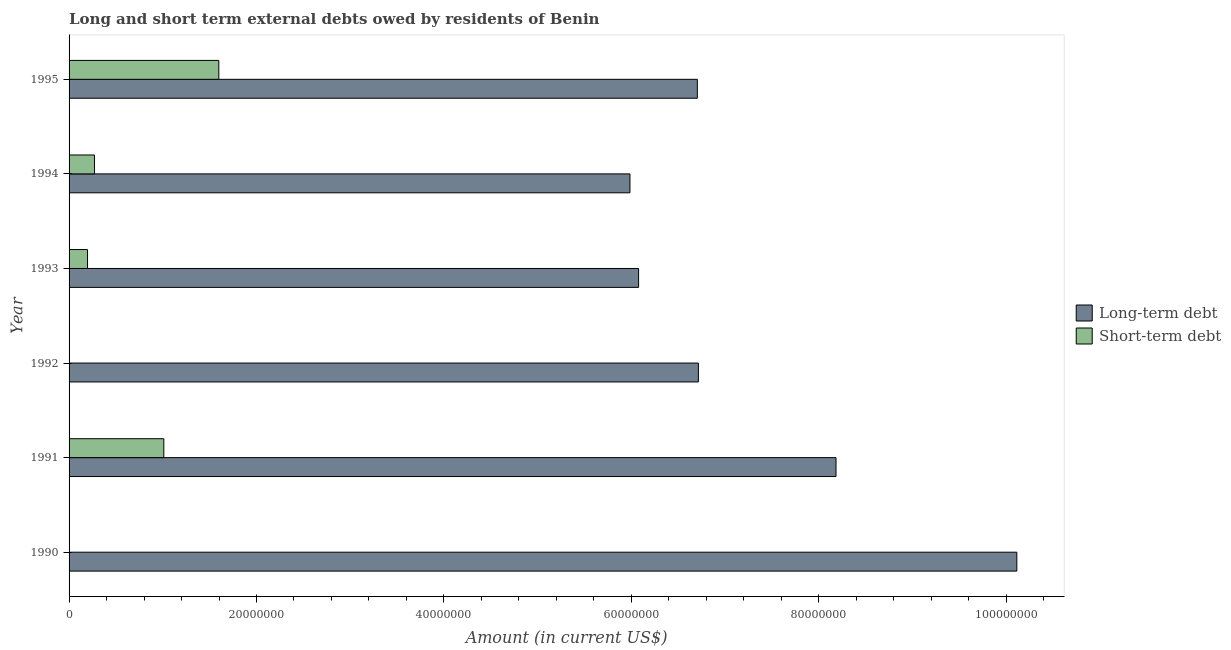Are the number of bars per tick equal to the number of legend labels?
Your answer should be very brief. No. Are the number of bars on each tick of the Y-axis equal?
Provide a short and direct response. No. How many bars are there on the 6th tick from the bottom?
Ensure brevity in your answer.  2. In how many cases, is the number of bars for a given year not equal to the number of legend labels?
Give a very brief answer. 2. What is the long-term debts owed by residents in 1991?
Offer a terse response. 8.18e+07. Across all years, what is the maximum long-term debts owed by residents?
Give a very brief answer. 1.01e+08. Across all years, what is the minimum long-term debts owed by residents?
Your answer should be compact. 5.99e+07. What is the total short-term debts owed by residents in the graph?
Your answer should be compact. 3.08e+07. What is the difference between the long-term debts owed by residents in 1990 and that in 1991?
Keep it short and to the point. 1.93e+07. What is the difference between the long-term debts owed by residents in 1994 and the short-term debts owed by residents in 1993?
Provide a succinct answer. 5.79e+07. What is the average long-term debts owed by residents per year?
Your answer should be compact. 7.30e+07. In the year 1995, what is the difference between the long-term debts owed by residents and short-term debts owed by residents?
Provide a succinct answer. 5.11e+07. In how many years, is the long-term debts owed by residents greater than 80000000 US$?
Offer a terse response. 2. What is the ratio of the long-term debts owed by residents in 1992 to that in 1995?
Give a very brief answer. 1. Is the short-term debts owed by residents in 1991 less than that in 1993?
Give a very brief answer. No. What is the difference between the highest and the second highest long-term debts owed by residents?
Give a very brief answer. 1.93e+07. What is the difference between the highest and the lowest short-term debts owed by residents?
Your answer should be very brief. 1.60e+07. Is the sum of the short-term debts owed by residents in 1991 and 1995 greater than the maximum long-term debts owed by residents across all years?
Ensure brevity in your answer.  No. Are all the bars in the graph horizontal?
Give a very brief answer. Yes. Does the graph contain any zero values?
Your answer should be compact. Yes. Does the graph contain grids?
Your response must be concise. No. Where does the legend appear in the graph?
Provide a short and direct response. Center right. How are the legend labels stacked?
Keep it short and to the point. Vertical. What is the title of the graph?
Give a very brief answer. Long and short term external debts owed by residents of Benin. Does "Pregnant women" appear as one of the legend labels in the graph?
Provide a succinct answer. No. What is the Amount (in current US$) in Long-term debt in 1990?
Make the answer very short. 1.01e+08. What is the Amount (in current US$) of Long-term debt in 1991?
Your response must be concise. 8.18e+07. What is the Amount (in current US$) of Short-term debt in 1991?
Make the answer very short. 1.01e+07. What is the Amount (in current US$) of Long-term debt in 1992?
Your answer should be very brief. 6.72e+07. What is the Amount (in current US$) of Long-term debt in 1993?
Your answer should be very brief. 6.08e+07. What is the Amount (in current US$) in Short-term debt in 1993?
Offer a very short reply. 1.97e+06. What is the Amount (in current US$) of Long-term debt in 1994?
Give a very brief answer. 5.99e+07. What is the Amount (in current US$) in Short-term debt in 1994?
Ensure brevity in your answer.  2.71e+06. What is the Amount (in current US$) in Long-term debt in 1995?
Offer a terse response. 6.70e+07. What is the Amount (in current US$) in Short-term debt in 1995?
Provide a succinct answer. 1.60e+07. Across all years, what is the maximum Amount (in current US$) of Long-term debt?
Your answer should be very brief. 1.01e+08. Across all years, what is the maximum Amount (in current US$) in Short-term debt?
Offer a terse response. 1.60e+07. Across all years, what is the minimum Amount (in current US$) in Long-term debt?
Keep it short and to the point. 5.99e+07. Across all years, what is the minimum Amount (in current US$) in Short-term debt?
Give a very brief answer. 0. What is the total Amount (in current US$) of Long-term debt in the graph?
Make the answer very short. 4.38e+08. What is the total Amount (in current US$) of Short-term debt in the graph?
Make the answer very short. 3.08e+07. What is the difference between the Amount (in current US$) in Long-term debt in 1990 and that in 1991?
Your answer should be very brief. 1.93e+07. What is the difference between the Amount (in current US$) in Long-term debt in 1990 and that in 1992?
Make the answer very short. 3.40e+07. What is the difference between the Amount (in current US$) in Long-term debt in 1990 and that in 1993?
Keep it short and to the point. 4.04e+07. What is the difference between the Amount (in current US$) in Long-term debt in 1990 and that in 1994?
Offer a terse response. 4.13e+07. What is the difference between the Amount (in current US$) of Long-term debt in 1990 and that in 1995?
Your answer should be compact. 3.41e+07. What is the difference between the Amount (in current US$) in Long-term debt in 1991 and that in 1992?
Your answer should be very brief. 1.47e+07. What is the difference between the Amount (in current US$) of Long-term debt in 1991 and that in 1993?
Your answer should be very brief. 2.11e+07. What is the difference between the Amount (in current US$) of Short-term debt in 1991 and that in 1993?
Give a very brief answer. 8.14e+06. What is the difference between the Amount (in current US$) of Long-term debt in 1991 and that in 1994?
Your answer should be compact. 2.20e+07. What is the difference between the Amount (in current US$) in Short-term debt in 1991 and that in 1994?
Keep it short and to the point. 7.40e+06. What is the difference between the Amount (in current US$) of Long-term debt in 1991 and that in 1995?
Give a very brief answer. 1.48e+07. What is the difference between the Amount (in current US$) of Short-term debt in 1991 and that in 1995?
Keep it short and to the point. -5.87e+06. What is the difference between the Amount (in current US$) of Long-term debt in 1992 and that in 1993?
Your response must be concise. 6.38e+06. What is the difference between the Amount (in current US$) in Long-term debt in 1992 and that in 1994?
Provide a short and direct response. 7.30e+06. What is the difference between the Amount (in current US$) of Long-term debt in 1992 and that in 1995?
Your answer should be very brief. 1.13e+05. What is the difference between the Amount (in current US$) in Long-term debt in 1993 and that in 1994?
Your answer should be compact. 9.23e+05. What is the difference between the Amount (in current US$) in Short-term debt in 1993 and that in 1994?
Give a very brief answer. -7.40e+05. What is the difference between the Amount (in current US$) in Long-term debt in 1993 and that in 1995?
Keep it short and to the point. -6.27e+06. What is the difference between the Amount (in current US$) in Short-term debt in 1993 and that in 1995?
Offer a very short reply. -1.40e+07. What is the difference between the Amount (in current US$) of Long-term debt in 1994 and that in 1995?
Keep it short and to the point. -7.19e+06. What is the difference between the Amount (in current US$) of Short-term debt in 1994 and that in 1995?
Give a very brief answer. -1.33e+07. What is the difference between the Amount (in current US$) of Long-term debt in 1990 and the Amount (in current US$) of Short-term debt in 1991?
Provide a succinct answer. 9.10e+07. What is the difference between the Amount (in current US$) of Long-term debt in 1990 and the Amount (in current US$) of Short-term debt in 1993?
Your answer should be compact. 9.92e+07. What is the difference between the Amount (in current US$) in Long-term debt in 1990 and the Amount (in current US$) in Short-term debt in 1994?
Offer a very short reply. 9.84e+07. What is the difference between the Amount (in current US$) of Long-term debt in 1990 and the Amount (in current US$) of Short-term debt in 1995?
Ensure brevity in your answer.  8.52e+07. What is the difference between the Amount (in current US$) of Long-term debt in 1991 and the Amount (in current US$) of Short-term debt in 1993?
Keep it short and to the point. 7.99e+07. What is the difference between the Amount (in current US$) of Long-term debt in 1991 and the Amount (in current US$) of Short-term debt in 1994?
Offer a terse response. 7.91e+07. What is the difference between the Amount (in current US$) in Long-term debt in 1991 and the Amount (in current US$) in Short-term debt in 1995?
Offer a very short reply. 6.59e+07. What is the difference between the Amount (in current US$) in Long-term debt in 1992 and the Amount (in current US$) in Short-term debt in 1993?
Keep it short and to the point. 6.52e+07. What is the difference between the Amount (in current US$) in Long-term debt in 1992 and the Amount (in current US$) in Short-term debt in 1994?
Make the answer very short. 6.44e+07. What is the difference between the Amount (in current US$) in Long-term debt in 1992 and the Amount (in current US$) in Short-term debt in 1995?
Offer a very short reply. 5.12e+07. What is the difference between the Amount (in current US$) in Long-term debt in 1993 and the Amount (in current US$) in Short-term debt in 1994?
Offer a very short reply. 5.81e+07. What is the difference between the Amount (in current US$) of Long-term debt in 1993 and the Amount (in current US$) of Short-term debt in 1995?
Offer a very short reply. 4.48e+07. What is the difference between the Amount (in current US$) in Long-term debt in 1994 and the Amount (in current US$) in Short-term debt in 1995?
Offer a terse response. 4.39e+07. What is the average Amount (in current US$) of Long-term debt per year?
Provide a succinct answer. 7.30e+07. What is the average Amount (in current US$) in Short-term debt per year?
Make the answer very short. 5.13e+06. In the year 1991, what is the difference between the Amount (in current US$) of Long-term debt and Amount (in current US$) of Short-term debt?
Offer a very short reply. 7.17e+07. In the year 1993, what is the difference between the Amount (in current US$) in Long-term debt and Amount (in current US$) in Short-term debt?
Ensure brevity in your answer.  5.88e+07. In the year 1994, what is the difference between the Amount (in current US$) in Long-term debt and Amount (in current US$) in Short-term debt?
Offer a very short reply. 5.71e+07. In the year 1995, what is the difference between the Amount (in current US$) in Long-term debt and Amount (in current US$) in Short-term debt?
Provide a succinct answer. 5.11e+07. What is the ratio of the Amount (in current US$) in Long-term debt in 1990 to that in 1991?
Your answer should be compact. 1.24. What is the ratio of the Amount (in current US$) in Long-term debt in 1990 to that in 1992?
Keep it short and to the point. 1.51. What is the ratio of the Amount (in current US$) of Long-term debt in 1990 to that in 1993?
Provide a succinct answer. 1.66. What is the ratio of the Amount (in current US$) in Long-term debt in 1990 to that in 1994?
Your answer should be very brief. 1.69. What is the ratio of the Amount (in current US$) of Long-term debt in 1990 to that in 1995?
Your answer should be compact. 1.51. What is the ratio of the Amount (in current US$) of Long-term debt in 1991 to that in 1992?
Your response must be concise. 1.22. What is the ratio of the Amount (in current US$) of Long-term debt in 1991 to that in 1993?
Give a very brief answer. 1.35. What is the ratio of the Amount (in current US$) in Short-term debt in 1991 to that in 1993?
Provide a short and direct response. 5.13. What is the ratio of the Amount (in current US$) in Long-term debt in 1991 to that in 1994?
Your response must be concise. 1.37. What is the ratio of the Amount (in current US$) of Short-term debt in 1991 to that in 1994?
Make the answer very short. 3.73. What is the ratio of the Amount (in current US$) of Long-term debt in 1991 to that in 1995?
Your response must be concise. 1.22. What is the ratio of the Amount (in current US$) of Short-term debt in 1991 to that in 1995?
Make the answer very short. 0.63. What is the ratio of the Amount (in current US$) of Long-term debt in 1992 to that in 1993?
Offer a terse response. 1.1. What is the ratio of the Amount (in current US$) in Long-term debt in 1992 to that in 1994?
Offer a terse response. 1.12. What is the ratio of the Amount (in current US$) of Long-term debt in 1992 to that in 1995?
Your answer should be very brief. 1. What is the ratio of the Amount (in current US$) of Long-term debt in 1993 to that in 1994?
Provide a succinct answer. 1.02. What is the ratio of the Amount (in current US$) of Short-term debt in 1993 to that in 1994?
Provide a succinct answer. 0.73. What is the ratio of the Amount (in current US$) of Long-term debt in 1993 to that in 1995?
Ensure brevity in your answer.  0.91. What is the ratio of the Amount (in current US$) in Short-term debt in 1993 to that in 1995?
Give a very brief answer. 0.12. What is the ratio of the Amount (in current US$) in Long-term debt in 1994 to that in 1995?
Give a very brief answer. 0.89. What is the ratio of the Amount (in current US$) of Short-term debt in 1994 to that in 1995?
Provide a succinct answer. 0.17. What is the difference between the highest and the second highest Amount (in current US$) in Long-term debt?
Make the answer very short. 1.93e+07. What is the difference between the highest and the second highest Amount (in current US$) of Short-term debt?
Make the answer very short. 5.87e+06. What is the difference between the highest and the lowest Amount (in current US$) in Long-term debt?
Provide a succinct answer. 4.13e+07. What is the difference between the highest and the lowest Amount (in current US$) in Short-term debt?
Keep it short and to the point. 1.60e+07. 